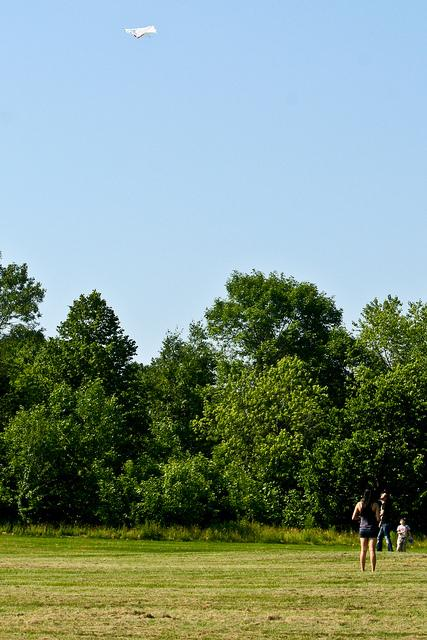What are the people standing in front of? Please explain your reasoning. trees. The people are by trees. 